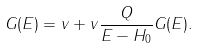<formula> <loc_0><loc_0><loc_500><loc_500>G ( E ) = v + v \frac { Q } { E - H _ { 0 } } G ( E ) .</formula> 